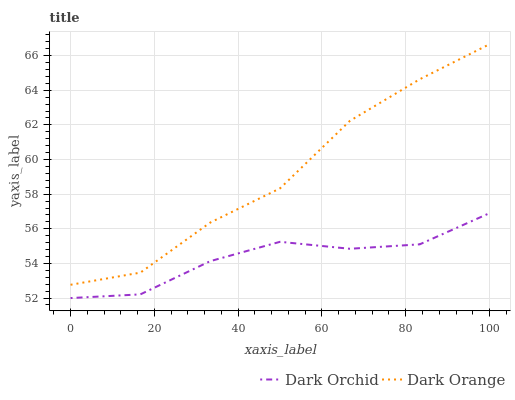Does Dark Orchid have the maximum area under the curve?
Answer yes or no. No. Is Dark Orchid the roughest?
Answer yes or no. No. Does Dark Orchid have the highest value?
Answer yes or no. No. Is Dark Orchid less than Dark Orange?
Answer yes or no. Yes. Is Dark Orange greater than Dark Orchid?
Answer yes or no. Yes. Does Dark Orchid intersect Dark Orange?
Answer yes or no. No. 